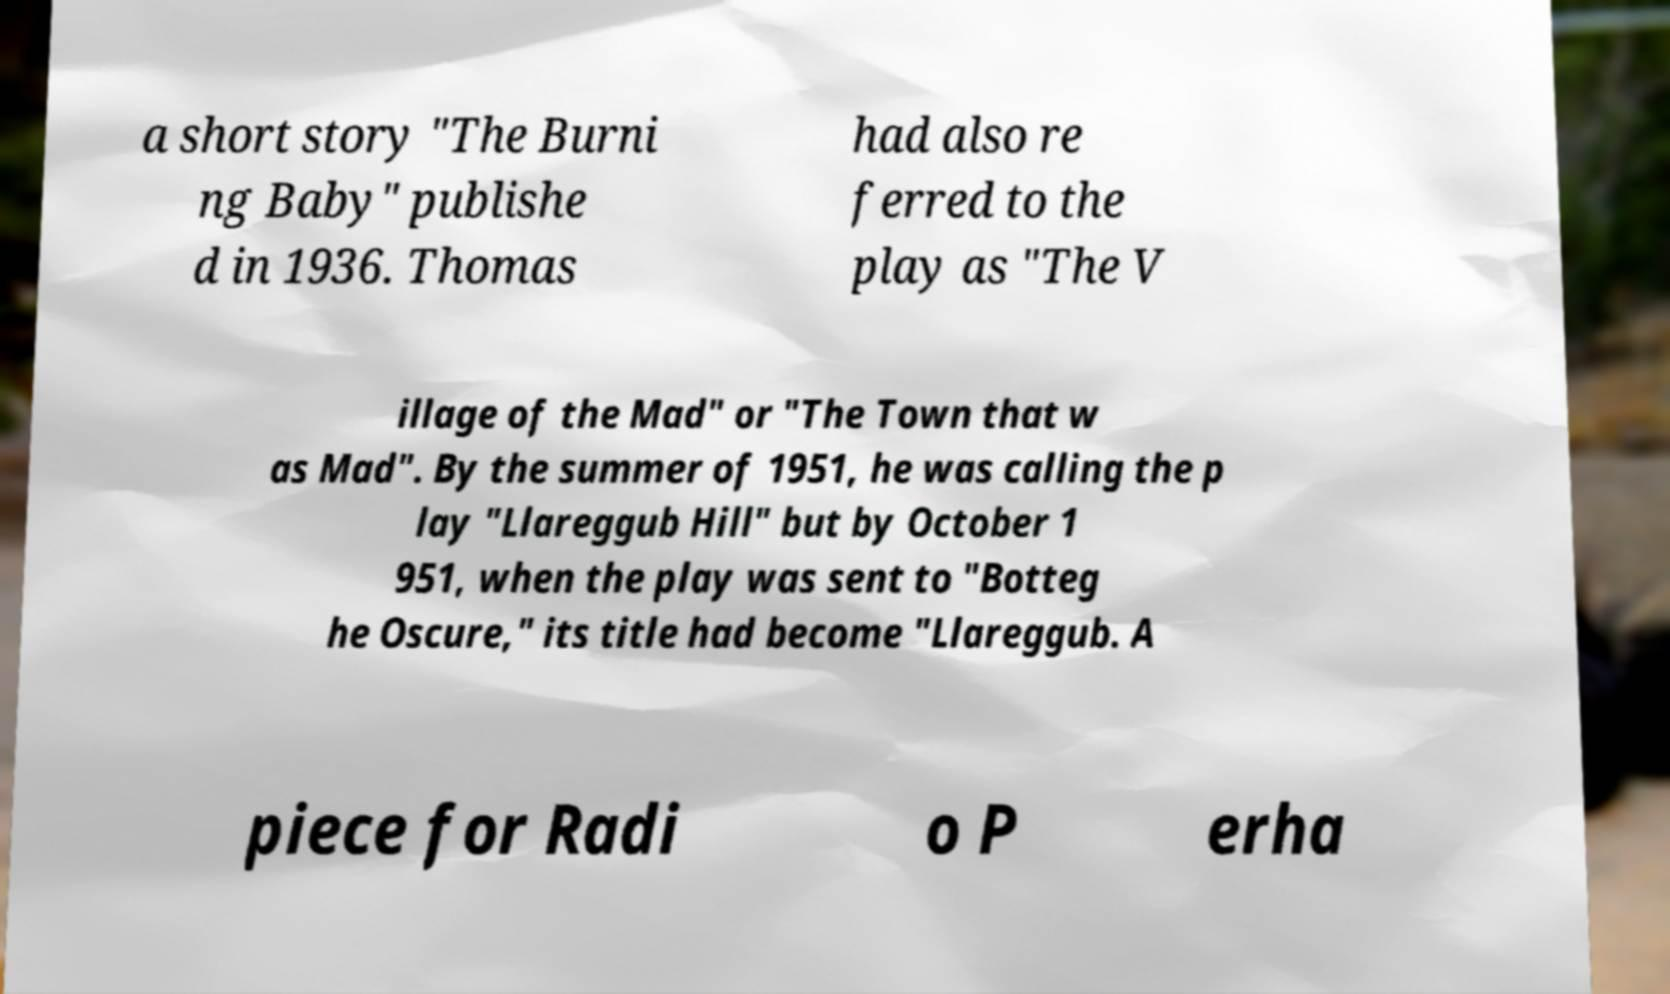Please read and relay the text visible in this image. What does it say? a short story "The Burni ng Baby" publishe d in 1936. Thomas had also re ferred to the play as "The V illage of the Mad" or "The Town that w as Mad". By the summer of 1951, he was calling the p lay "Llareggub Hill" but by October 1 951, when the play was sent to "Botteg he Oscure," its title had become "Llareggub. A piece for Radi o P erha 